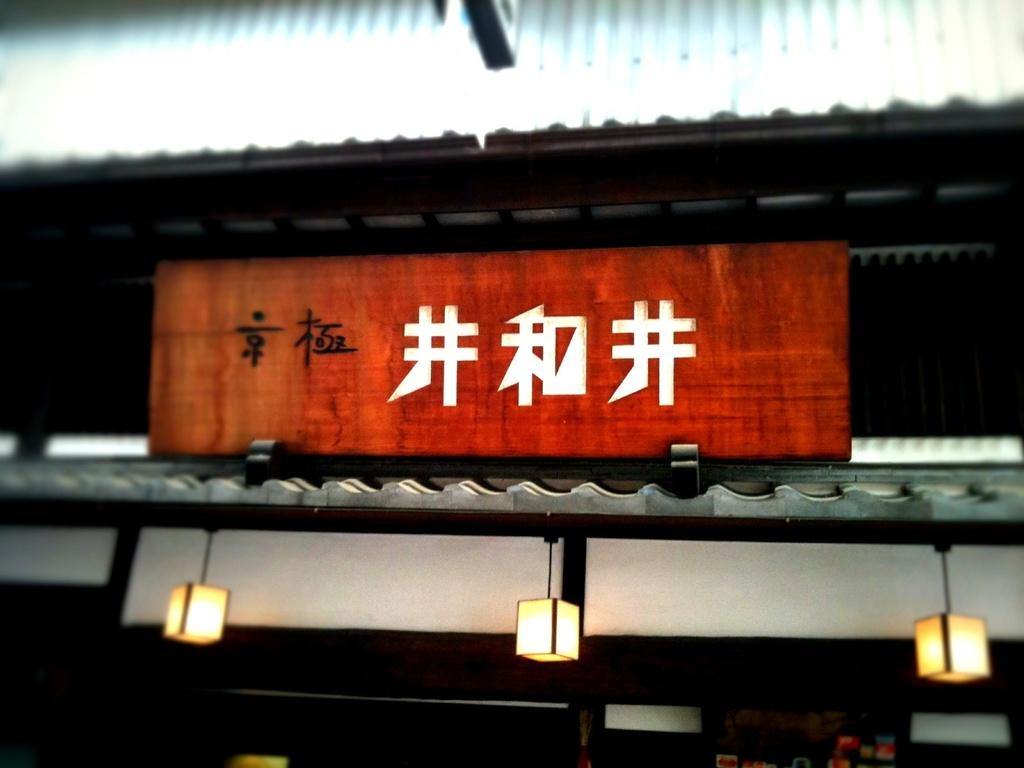What type of structure is present in the image? There is a shed in the image. What is written or displayed on a board in the image? There is a board with text in the image. What type of architectural feature is visible in the image? There is a wall visible in the image. What can be used to provide illumination in the image? There are lights in the image. What objects can be seen at the bottom of the image? There are objects at the bottom of the image. What type of disgust can be seen on the face of the person holding a basketball in the image? There is no person holding a basketball in the image, nor is there any indication of disgust. 